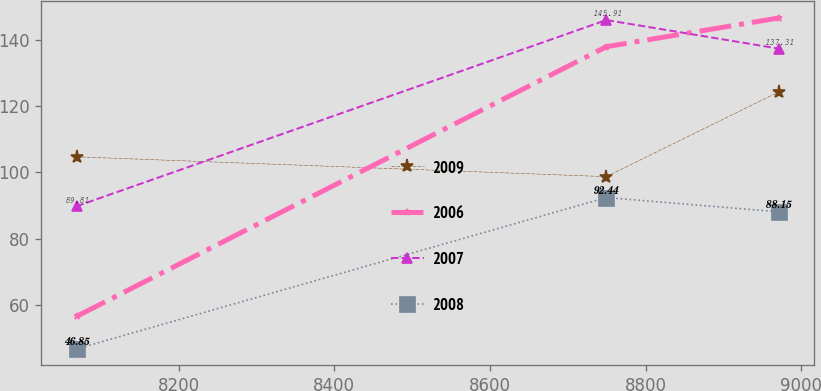Convert chart to OTSL. <chart><loc_0><loc_0><loc_500><loc_500><line_chart><ecel><fcel>2009<fcel>2006<fcel>2007<fcel>2008<nl><fcel>8068.7<fcel>104.71<fcel>56.65<fcel>89.81<fcel>46.85<nl><fcel>8749.51<fcel>98.74<fcel>137.88<fcel>145.91<fcel>92.44<nl><fcel>8970.83<fcel>124.24<fcel>146.53<fcel>137.31<fcel>88.15<nl></chart> 